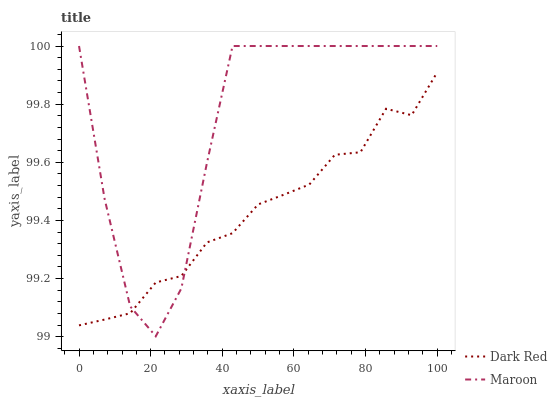Does Dark Red have the minimum area under the curve?
Answer yes or no. Yes. Does Maroon have the maximum area under the curve?
Answer yes or no. Yes. Does Maroon have the minimum area under the curve?
Answer yes or no. No. Is Dark Red the smoothest?
Answer yes or no. Yes. Is Maroon the roughest?
Answer yes or no. Yes. Is Maroon the smoothest?
Answer yes or no. No. 